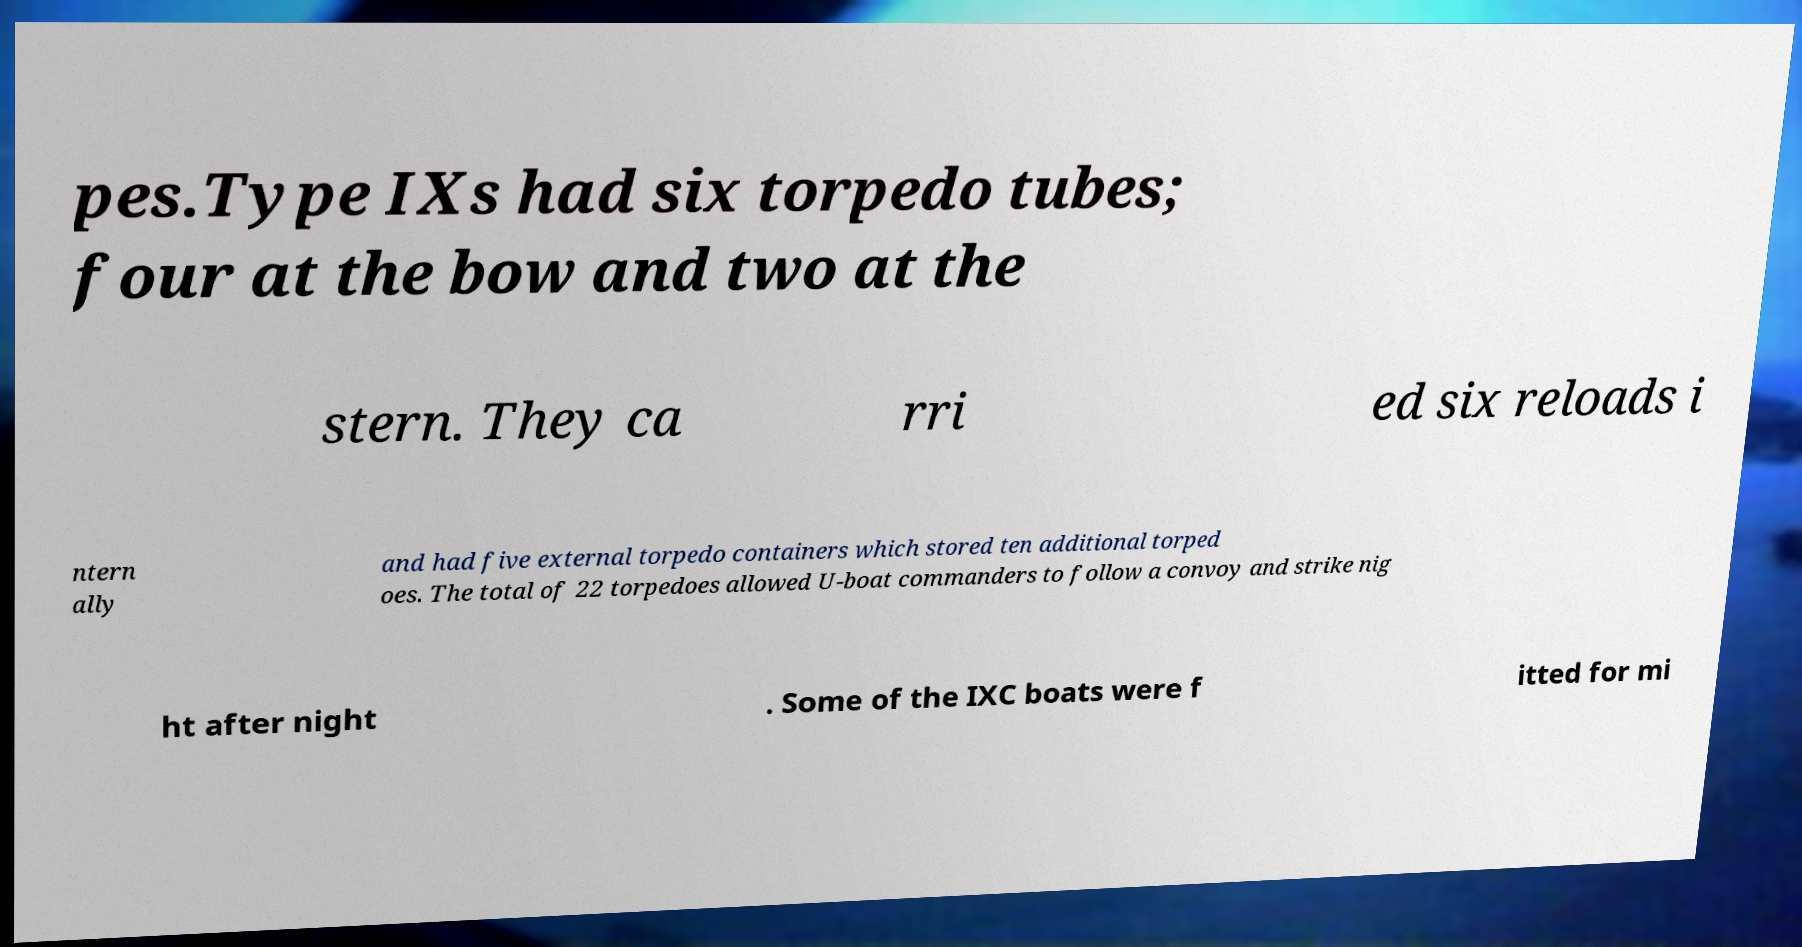What messages or text are displayed in this image? I need them in a readable, typed format. pes.Type IXs had six torpedo tubes; four at the bow and two at the stern. They ca rri ed six reloads i ntern ally and had five external torpedo containers which stored ten additional torped oes. The total of 22 torpedoes allowed U-boat commanders to follow a convoy and strike nig ht after night . Some of the IXC boats were f itted for mi 